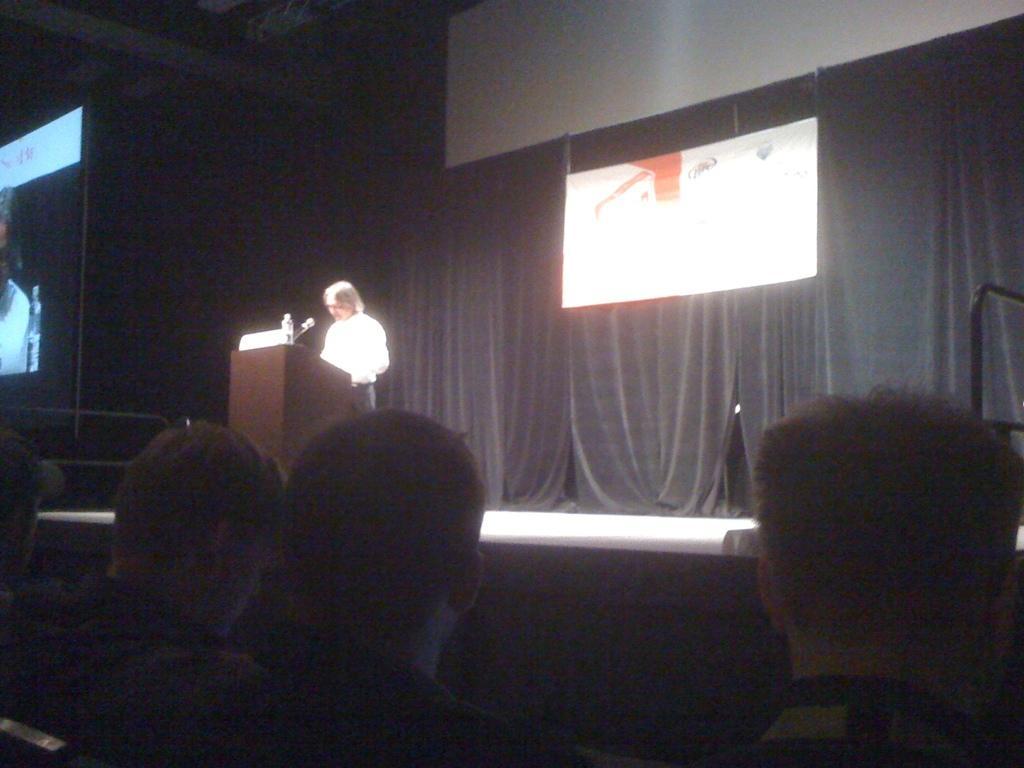Could you give a brief overview of what you see in this image? As we can see in the image there are few people here and there, screen, banner, curtains, bottles and a mic. 